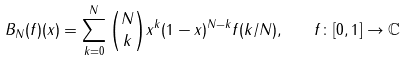Convert formula to latex. <formula><loc_0><loc_0><loc_500><loc_500>B _ { N } ( f ) ( x ) = \sum _ { k = 0 } ^ { N } { N \choose k } x ^ { k } ( 1 - x ) ^ { N - k } f ( k / N ) , \quad f \colon [ 0 , 1 ] \to \mathbb { C }</formula> 